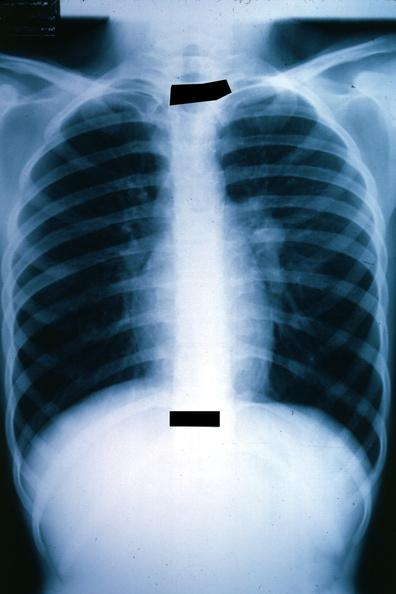what is present?
Answer the question using a single word or phrase. Lung 